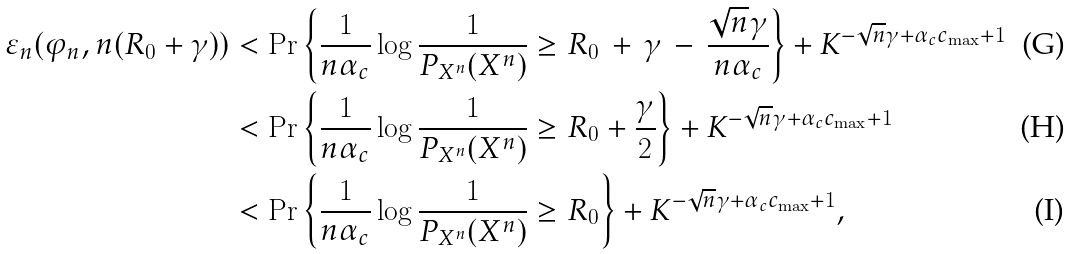<formula> <loc_0><loc_0><loc_500><loc_500>\varepsilon _ { n } ( \varphi _ { n } , n ( R _ { 0 } + \gamma ) ) & < \Pr \left \{ \frac { 1 } { n \alpha _ { c } } \log \frac { 1 } { P _ { X ^ { n } } ( X ^ { n } ) } \geq R _ { 0 } \, + \, \gamma \, - \, \frac { \sqrt { n } \gamma } { n \alpha _ { c } } \right \} + K ^ { - \sqrt { n } \gamma + \alpha _ { c } c _ { \max } + 1 } \\ & < \Pr \left \{ \frac { 1 } { n \alpha _ { c } } \log \frac { 1 } { P _ { X ^ { n } } ( X ^ { n } ) } \geq R _ { 0 } + \frac { \gamma } { 2 } \right \} + K ^ { - \sqrt { n } \gamma + \alpha _ { c } c _ { \max } + 1 } \\ & < \Pr \left \{ \frac { 1 } { n \alpha _ { c } } \log \frac { 1 } { P _ { X ^ { n } } ( X ^ { n } ) } \geq R _ { 0 } \right \} + K ^ { - \sqrt { n } \gamma + \alpha _ { c } c _ { \max } + 1 } ,</formula> 